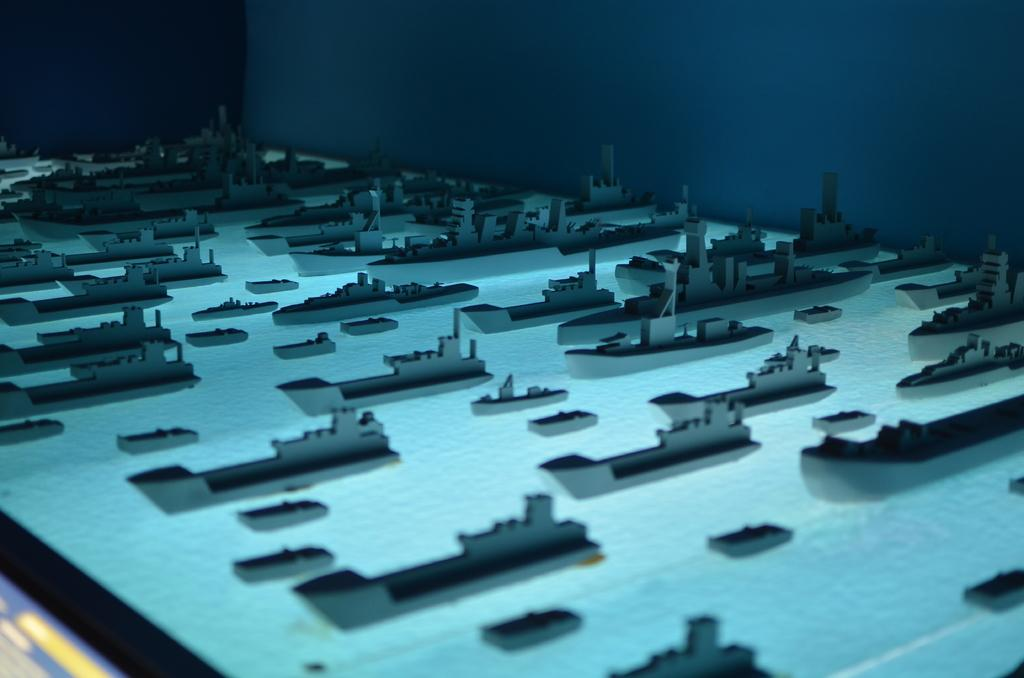What type of scene is shown in the image? The image depicts an architectural scene. What can be seen floating on the water in the image? There are boats on the board in the image. What structure is visible in the background of the image? There is a wall visible in the background of the image. What type of thrill can be experienced in the room shown in the image? There is no room shown in the image; it depicts an architectural scene with boats and a wall. 